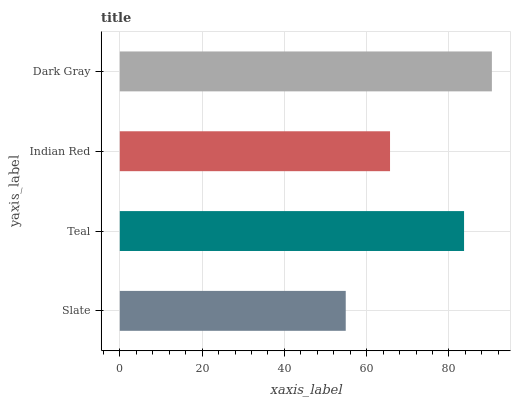Is Slate the minimum?
Answer yes or no. Yes. Is Dark Gray the maximum?
Answer yes or no. Yes. Is Teal the minimum?
Answer yes or no. No. Is Teal the maximum?
Answer yes or no. No. Is Teal greater than Slate?
Answer yes or no. Yes. Is Slate less than Teal?
Answer yes or no. Yes. Is Slate greater than Teal?
Answer yes or no. No. Is Teal less than Slate?
Answer yes or no. No. Is Teal the high median?
Answer yes or no. Yes. Is Indian Red the low median?
Answer yes or no. Yes. Is Slate the high median?
Answer yes or no. No. Is Slate the low median?
Answer yes or no. No. 